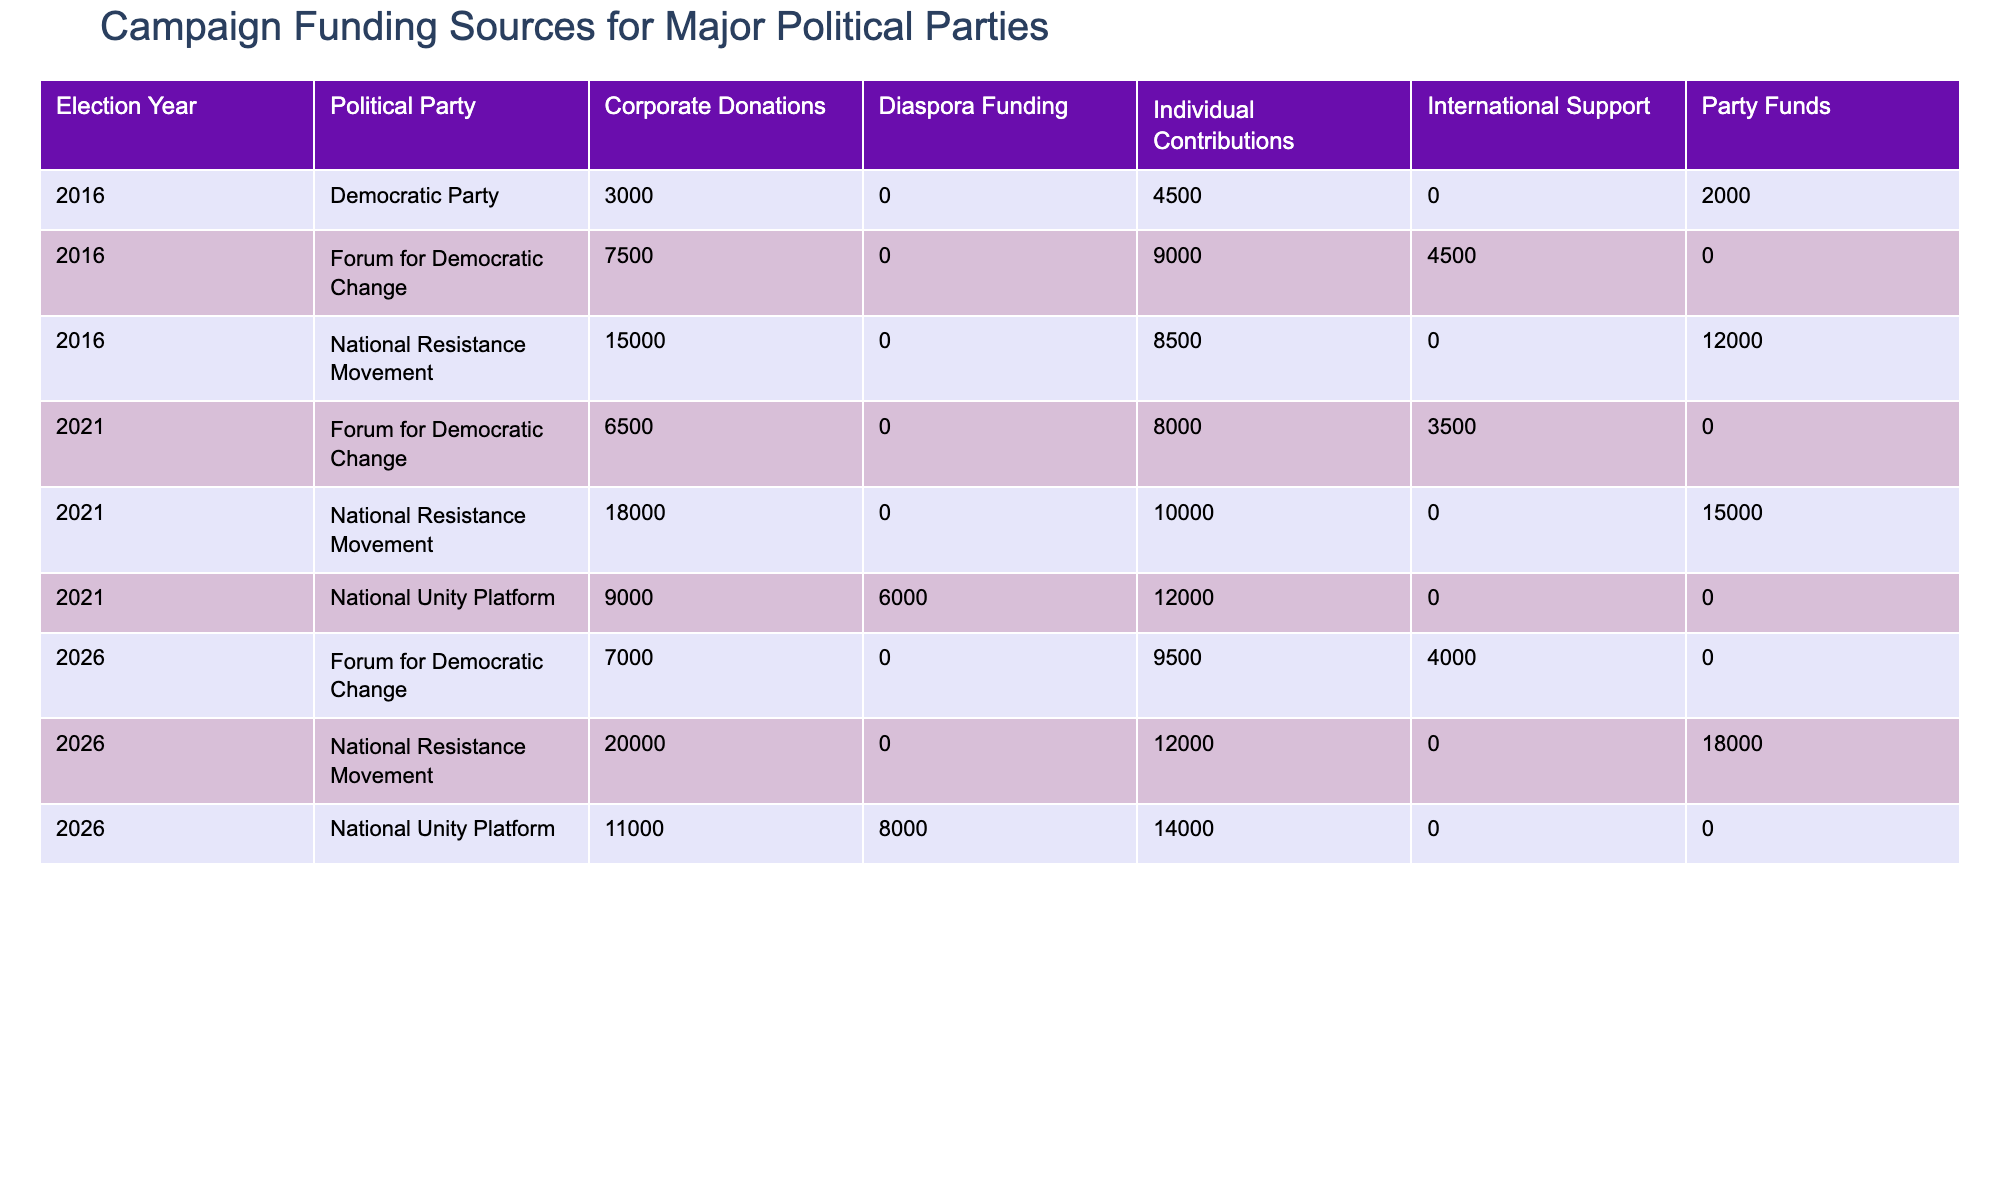What was the total amount funded to the National Resistance Movement in the 2021 election? To find the total funding for the National Resistance Movement in 2021, we look at the three funding sources in the table: Corporate Donations (18000), Individual Contributions (10000), and Party Funds (15000). Adding these values together gives us 18000 + 10000 + 15000 = 43000 million UGX.
Answer: 43000 million UGX Which party received the most funding from Corporate Donations in the last three elections? By examining the Corporate Donations row for each party over the three elections, we find that National Resistance Movement received 15000 million UGX in 2016, 18000 million UGX in 2021, and 20000 million UGX in 2026. The National Unity Platform received 9000 million UGX in 2021 and 11000 million UGX in 2026. Forum for Democratic Change received 7500 million UGX in 2016, 6500 million UGX in 2021, and 7000 million UGX in 2026. Summing up the Corporate Donations across the years, National Resistance Movement has the highest total with 15000 + 18000 + 20000 = 53000 million UGX.
Answer: National Resistance Movement Did the Forum for Democratic Change receive any diaspora funding in the last three elections? Looking at the funding sources for the Forum for Democratic Change, there are no records of diaspora funding in any of the elections listed from 2016, 2021, or 2026. Therefore, the statement is false.
Answer: No What was the average amount received by the National Unity Platform from Individual Contributions across the three elections? The National Unity Platform received 12000 million UGX in 2021 and 14000 million UGX in 2026 from Individual Contributions. There are two data points, and to find the average, we sum these amounts (12000 + 14000 = 26000 million UGX) and divide by 2, resulting in an average of 26000 / 2 = 13000 million UGX.
Answer: 13000 million UGX In which election did the Democratic Party have the least total funding across all sources? To determine this, we look at the total funding sources for the Democratic Party in each election: In 2016, they received 3000 million UGX (Corporate Donations) + 4500 million UGX (Individual Contributions) + 2000 million UGX (Party Funds), totaling 9500 million UGX. In 2021, they received no funding, totaling 0 million UGX. In 2026, they are not present in the funding data, maintaining the total as 0 million UGX. Hence, the least total funding is in 2021 and 2026.
Answer: 2021 and 2026 Which funding source contributed to the highest total amount for the National Resistance Movement across the three elections? To find this, we examine each funding source for National Resistance Movement. The total for Corporate Donations is 15000 + 18000 + 20000 = 53000 million UGX. For Individual Contributions, it's 8500 + 10000 + 12000 = 30500 million UGX. For Party Funds, it's 12000 + 15000 + 18000 = 45000 million UGX. Therefore, Corporate Donations contributed the highest total amount of 53000 million UGX.
Answer: Corporate Donations 